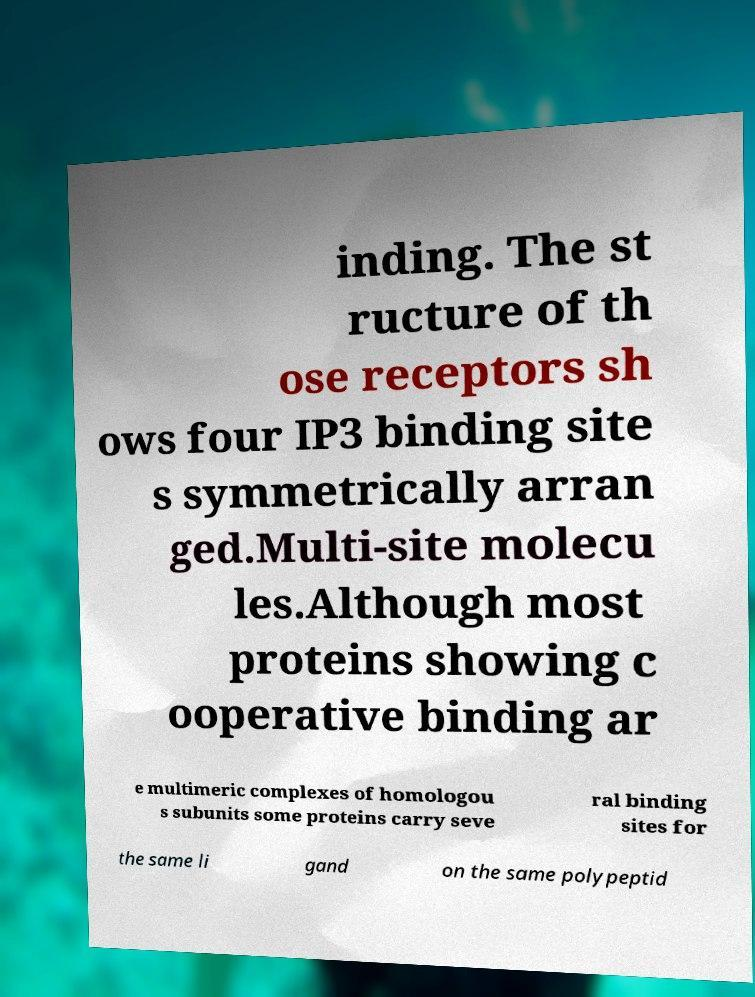Can you accurately transcribe the text from the provided image for me? inding. The st ructure of th ose receptors sh ows four IP3 binding site s symmetrically arran ged.Multi-site molecu les.Although most proteins showing c ooperative binding ar e multimeric complexes of homologou s subunits some proteins carry seve ral binding sites for the same li gand on the same polypeptid 